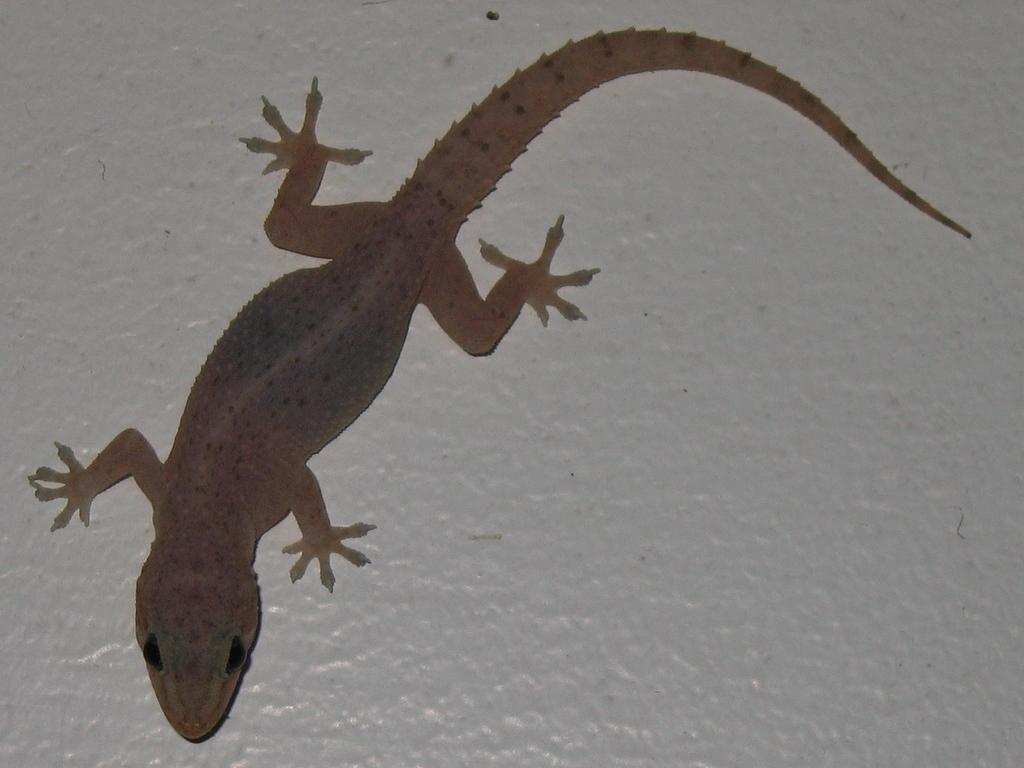What type of animal is in the image? There is a lizard in the image. What is the lizard positioned on in the image? The lizard is on an object. What type of magic does the mother pig perform with the lizard in the image? There is no pig or magic present in the image; it features a lizard on an object. 